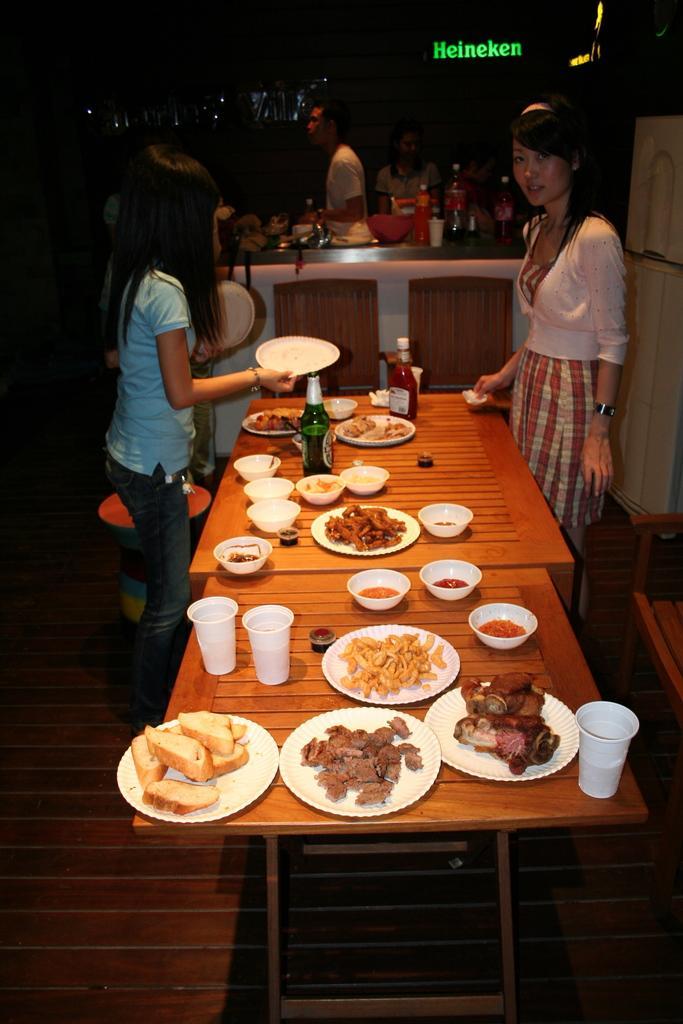How would you summarize this image in a sentence or two? In this image there were few people. In the right side of the image a girl is standing in front of table. In the left side of the image a girl is standing holding a plate in her hand. In the middle of the image there is a table on which there is a food, plates, bowls, bottles and glasses. At the top of the image there is a text. 